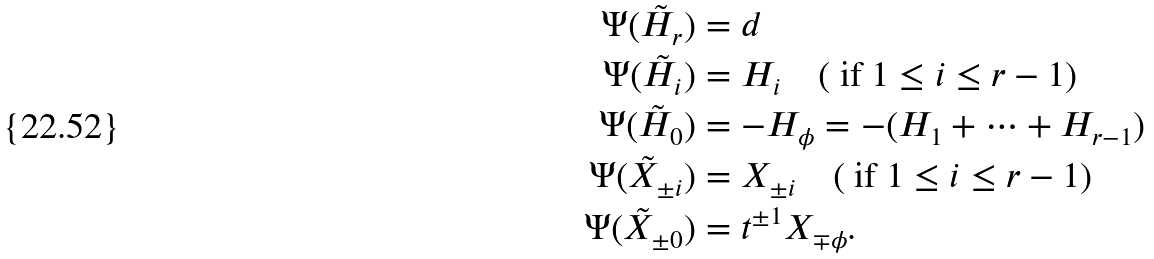Convert formula to latex. <formula><loc_0><loc_0><loc_500><loc_500>\Psi ( \tilde { H } _ { r } ) & = d \\ \Psi ( \tilde { H } _ { i } ) & = H _ { i } \quad ( \text { if } 1 \leq i \leq r - 1 ) \\ \Psi ( \tilde { H } _ { 0 } ) & = - H _ { \phi } = - ( H _ { 1 } + \dots + H _ { r - 1 } ) \\ \Psi ( \tilde { X } _ { \pm i } ) & = X _ { \pm i } \quad ( \text { if } 1 \leq i \leq r - 1 ) \\ \Psi ( \tilde { X } _ { \pm 0 } ) & = t ^ { \pm 1 } X _ { \mp \phi } .</formula> 